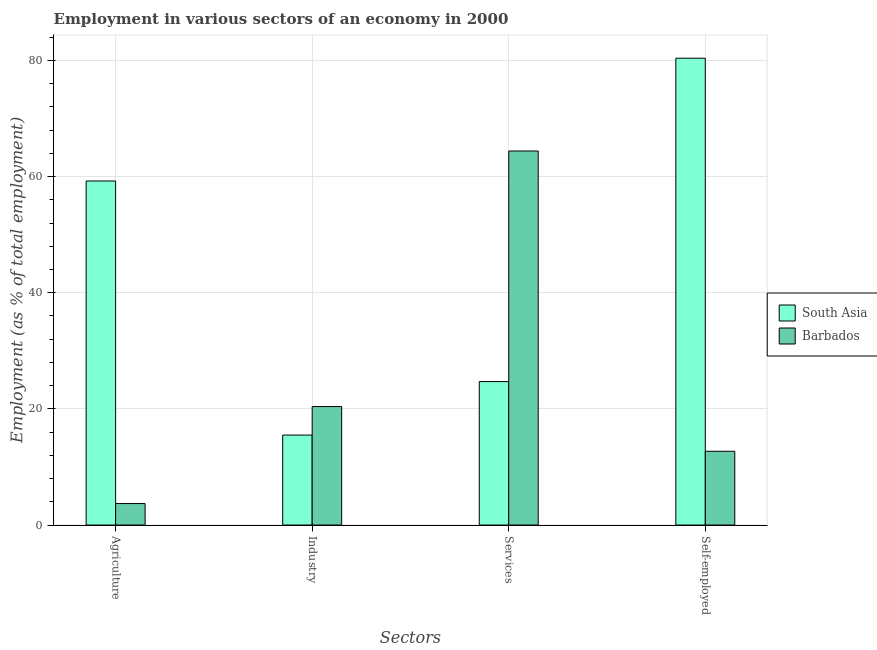How many different coloured bars are there?
Provide a succinct answer. 2. Are the number of bars per tick equal to the number of legend labels?
Make the answer very short. Yes. Are the number of bars on each tick of the X-axis equal?
Provide a succinct answer. Yes. What is the label of the 2nd group of bars from the left?
Give a very brief answer. Industry. What is the percentage of self employed workers in South Asia?
Provide a short and direct response. 80.37. Across all countries, what is the maximum percentage of self employed workers?
Your answer should be compact. 80.37. Across all countries, what is the minimum percentage of self employed workers?
Ensure brevity in your answer.  12.7. In which country was the percentage of workers in agriculture maximum?
Provide a short and direct response. South Asia. In which country was the percentage of workers in agriculture minimum?
Provide a short and direct response. Barbados. What is the total percentage of workers in industry in the graph?
Your answer should be compact. 35.89. What is the difference between the percentage of workers in industry in Barbados and that in South Asia?
Keep it short and to the point. 4.91. What is the difference between the percentage of workers in agriculture in Barbados and the percentage of workers in industry in South Asia?
Offer a very short reply. -11.79. What is the average percentage of workers in agriculture per country?
Provide a short and direct response. 31.47. What is the difference between the percentage of workers in agriculture and percentage of workers in services in South Asia?
Make the answer very short. 34.53. In how many countries, is the percentage of workers in industry greater than 24 %?
Provide a short and direct response. 0. What is the ratio of the percentage of workers in industry in Barbados to that in South Asia?
Your answer should be compact. 1.32. Is the percentage of workers in agriculture in Barbados less than that in South Asia?
Give a very brief answer. Yes. Is the difference between the percentage of self employed workers in South Asia and Barbados greater than the difference between the percentage of workers in services in South Asia and Barbados?
Offer a very short reply. Yes. What is the difference between the highest and the second highest percentage of workers in services?
Offer a terse response. 39.7. What is the difference between the highest and the lowest percentage of workers in agriculture?
Offer a terse response. 55.53. Is it the case that in every country, the sum of the percentage of self employed workers and percentage of workers in agriculture is greater than the sum of percentage of workers in services and percentage of workers in industry?
Ensure brevity in your answer.  No. What does the 2nd bar from the left in Services represents?
Your answer should be compact. Barbados. What does the 2nd bar from the right in Self-employed represents?
Offer a very short reply. South Asia. Is it the case that in every country, the sum of the percentage of workers in agriculture and percentage of workers in industry is greater than the percentage of workers in services?
Provide a short and direct response. No. Are the values on the major ticks of Y-axis written in scientific E-notation?
Make the answer very short. No. Does the graph contain any zero values?
Give a very brief answer. No. Does the graph contain grids?
Your answer should be compact. Yes. How are the legend labels stacked?
Your response must be concise. Vertical. What is the title of the graph?
Make the answer very short. Employment in various sectors of an economy in 2000. Does "Mauritius" appear as one of the legend labels in the graph?
Ensure brevity in your answer.  No. What is the label or title of the X-axis?
Provide a succinct answer. Sectors. What is the label or title of the Y-axis?
Keep it short and to the point. Employment (as % of total employment). What is the Employment (as % of total employment) of South Asia in Agriculture?
Your response must be concise. 59.23. What is the Employment (as % of total employment) in Barbados in Agriculture?
Keep it short and to the point. 3.7. What is the Employment (as % of total employment) in South Asia in Industry?
Make the answer very short. 15.49. What is the Employment (as % of total employment) in Barbados in Industry?
Keep it short and to the point. 20.4. What is the Employment (as % of total employment) in South Asia in Services?
Your answer should be compact. 24.7. What is the Employment (as % of total employment) in Barbados in Services?
Ensure brevity in your answer.  64.4. What is the Employment (as % of total employment) of South Asia in Self-employed?
Your response must be concise. 80.37. What is the Employment (as % of total employment) in Barbados in Self-employed?
Give a very brief answer. 12.7. Across all Sectors, what is the maximum Employment (as % of total employment) in South Asia?
Keep it short and to the point. 80.37. Across all Sectors, what is the maximum Employment (as % of total employment) of Barbados?
Give a very brief answer. 64.4. Across all Sectors, what is the minimum Employment (as % of total employment) in South Asia?
Ensure brevity in your answer.  15.49. Across all Sectors, what is the minimum Employment (as % of total employment) in Barbados?
Offer a very short reply. 3.7. What is the total Employment (as % of total employment) in South Asia in the graph?
Your response must be concise. 179.8. What is the total Employment (as % of total employment) in Barbados in the graph?
Your response must be concise. 101.2. What is the difference between the Employment (as % of total employment) of South Asia in Agriculture and that in Industry?
Your answer should be very brief. 43.74. What is the difference between the Employment (as % of total employment) in Barbados in Agriculture and that in Industry?
Ensure brevity in your answer.  -16.7. What is the difference between the Employment (as % of total employment) in South Asia in Agriculture and that in Services?
Offer a very short reply. 34.53. What is the difference between the Employment (as % of total employment) of Barbados in Agriculture and that in Services?
Your answer should be compact. -60.7. What is the difference between the Employment (as % of total employment) of South Asia in Agriculture and that in Self-employed?
Offer a very short reply. -21.14. What is the difference between the Employment (as % of total employment) in Barbados in Agriculture and that in Self-employed?
Ensure brevity in your answer.  -9. What is the difference between the Employment (as % of total employment) of South Asia in Industry and that in Services?
Offer a terse response. -9.21. What is the difference between the Employment (as % of total employment) of Barbados in Industry and that in Services?
Provide a short and direct response. -44. What is the difference between the Employment (as % of total employment) of South Asia in Industry and that in Self-employed?
Ensure brevity in your answer.  -64.88. What is the difference between the Employment (as % of total employment) in South Asia in Services and that in Self-employed?
Offer a very short reply. -55.67. What is the difference between the Employment (as % of total employment) in Barbados in Services and that in Self-employed?
Give a very brief answer. 51.7. What is the difference between the Employment (as % of total employment) of South Asia in Agriculture and the Employment (as % of total employment) of Barbados in Industry?
Ensure brevity in your answer.  38.83. What is the difference between the Employment (as % of total employment) of South Asia in Agriculture and the Employment (as % of total employment) of Barbados in Services?
Make the answer very short. -5.17. What is the difference between the Employment (as % of total employment) in South Asia in Agriculture and the Employment (as % of total employment) in Barbados in Self-employed?
Provide a short and direct response. 46.53. What is the difference between the Employment (as % of total employment) of South Asia in Industry and the Employment (as % of total employment) of Barbados in Services?
Provide a short and direct response. -48.91. What is the difference between the Employment (as % of total employment) in South Asia in Industry and the Employment (as % of total employment) in Barbados in Self-employed?
Give a very brief answer. 2.79. What is the difference between the Employment (as % of total employment) in South Asia in Services and the Employment (as % of total employment) in Barbados in Self-employed?
Keep it short and to the point. 12. What is the average Employment (as % of total employment) of South Asia per Sectors?
Give a very brief answer. 44.95. What is the average Employment (as % of total employment) in Barbados per Sectors?
Provide a short and direct response. 25.3. What is the difference between the Employment (as % of total employment) of South Asia and Employment (as % of total employment) of Barbados in Agriculture?
Offer a very short reply. 55.53. What is the difference between the Employment (as % of total employment) of South Asia and Employment (as % of total employment) of Barbados in Industry?
Offer a very short reply. -4.91. What is the difference between the Employment (as % of total employment) in South Asia and Employment (as % of total employment) in Barbados in Services?
Make the answer very short. -39.7. What is the difference between the Employment (as % of total employment) of South Asia and Employment (as % of total employment) of Barbados in Self-employed?
Make the answer very short. 67.67. What is the ratio of the Employment (as % of total employment) of South Asia in Agriculture to that in Industry?
Your answer should be compact. 3.82. What is the ratio of the Employment (as % of total employment) in Barbados in Agriculture to that in Industry?
Your response must be concise. 0.18. What is the ratio of the Employment (as % of total employment) in South Asia in Agriculture to that in Services?
Provide a succinct answer. 2.4. What is the ratio of the Employment (as % of total employment) of Barbados in Agriculture to that in Services?
Make the answer very short. 0.06. What is the ratio of the Employment (as % of total employment) in South Asia in Agriculture to that in Self-employed?
Give a very brief answer. 0.74. What is the ratio of the Employment (as % of total employment) of Barbados in Agriculture to that in Self-employed?
Your answer should be compact. 0.29. What is the ratio of the Employment (as % of total employment) of South Asia in Industry to that in Services?
Give a very brief answer. 0.63. What is the ratio of the Employment (as % of total employment) of Barbados in Industry to that in Services?
Provide a short and direct response. 0.32. What is the ratio of the Employment (as % of total employment) in South Asia in Industry to that in Self-employed?
Keep it short and to the point. 0.19. What is the ratio of the Employment (as % of total employment) of Barbados in Industry to that in Self-employed?
Your response must be concise. 1.61. What is the ratio of the Employment (as % of total employment) in South Asia in Services to that in Self-employed?
Provide a succinct answer. 0.31. What is the ratio of the Employment (as % of total employment) of Barbados in Services to that in Self-employed?
Offer a terse response. 5.07. What is the difference between the highest and the second highest Employment (as % of total employment) in South Asia?
Ensure brevity in your answer.  21.14. What is the difference between the highest and the second highest Employment (as % of total employment) in Barbados?
Keep it short and to the point. 44. What is the difference between the highest and the lowest Employment (as % of total employment) in South Asia?
Provide a short and direct response. 64.88. What is the difference between the highest and the lowest Employment (as % of total employment) of Barbados?
Offer a terse response. 60.7. 